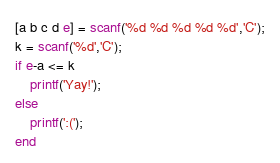<code> <loc_0><loc_0><loc_500><loc_500><_Octave_>[a b c d e] = scanf('%d %d %d %d %d','C');
k = scanf('%d','C');
if e-a <= k
	printf('Yay!');
else
	printf(':(');
end
</code> 